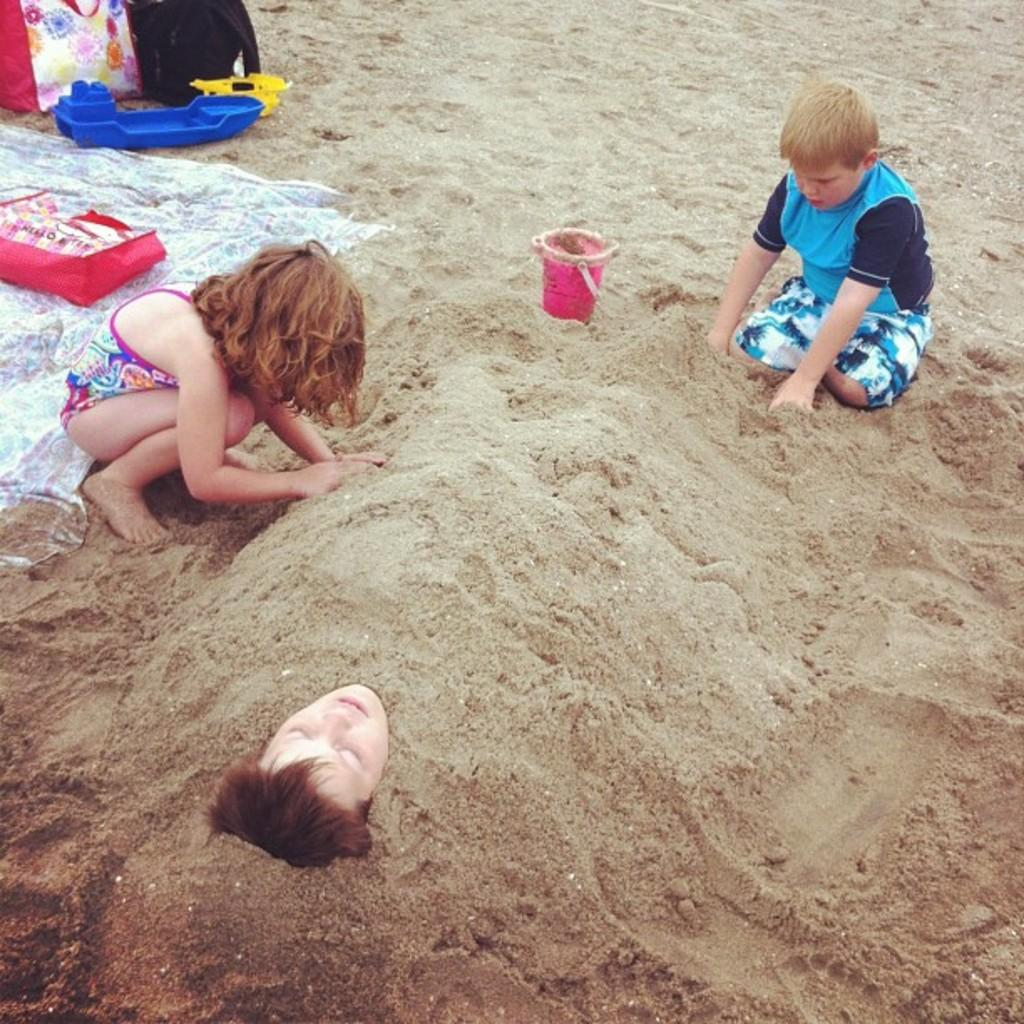What is the person in the image doing? The person is in the sand, which suggests they might be playing or relaxing. Who else is present in the image? There are kids sitting near the person. What else can be seen in the image? There are toys and bags visible. What type of horses can be seen running in the background of the image? There are no horses present in the image; it features a person and kids in the sand with toys and bags. 